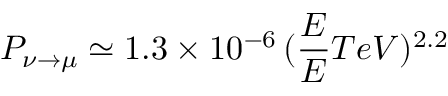Convert formula to latex. <formula><loc_0><loc_0><loc_500><loc_500>P _ { \nu \to \mu } \simeq 1 . 3 \times 1 0 ^ { - 6 } \, ( \frac { E } { E } { T e V } ) ^ { 2 . 2 }</formula> 